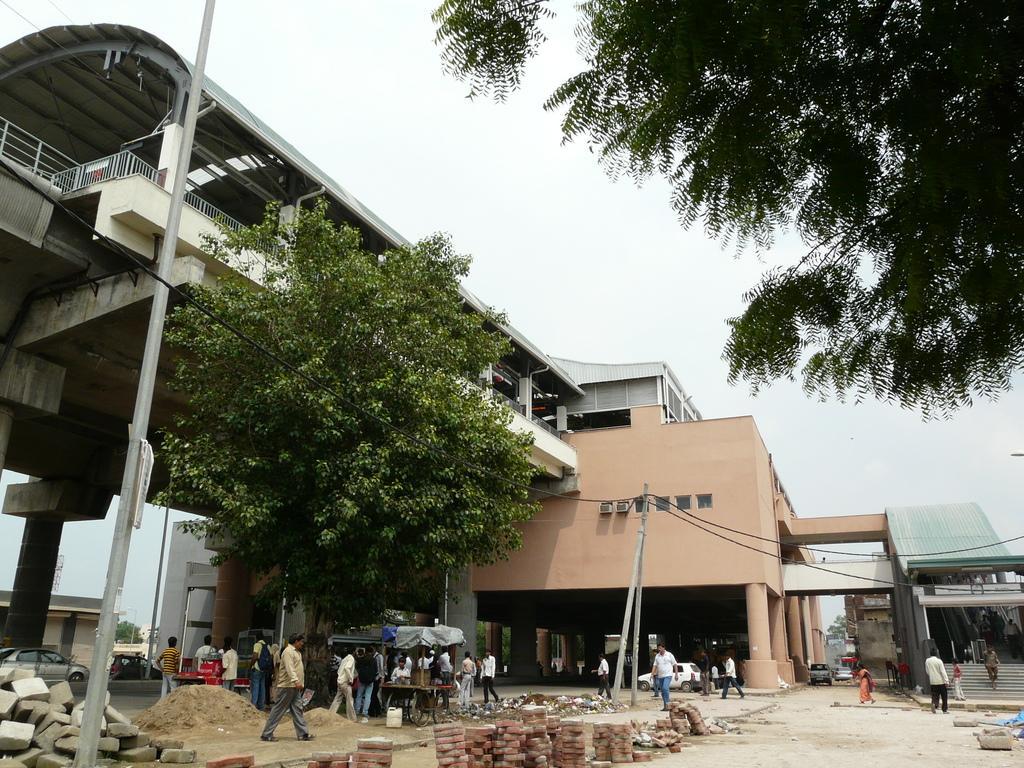Can you describe this image briefly? In this picture I can see the path in front on which there are number of stones, sand and number of people. On the left side of this image I can see a pole. In the background I can see the buildings, few trees, few poles, wires and the sky. I can also see few vehicles. 